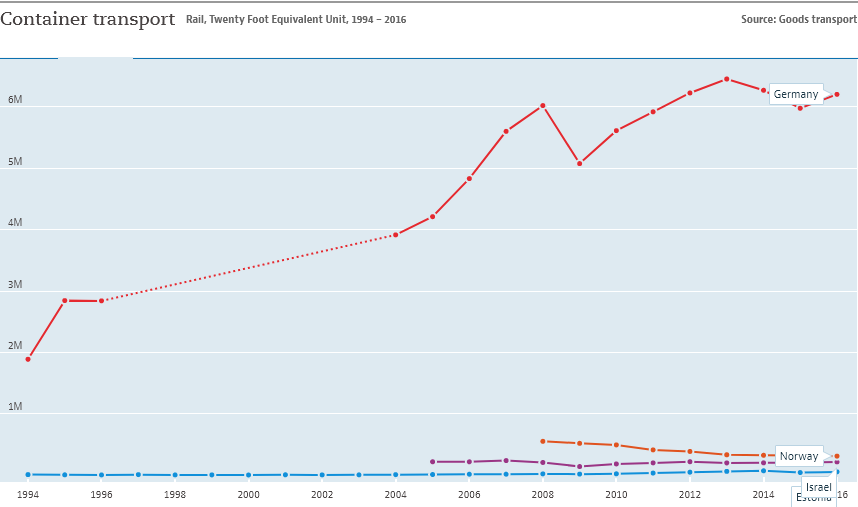Outline some significant characteristics in this image. The country represented by the red color line is Germany. According to records, there have been countries that have transported containers in excess of 3 million metric tons over the years. 